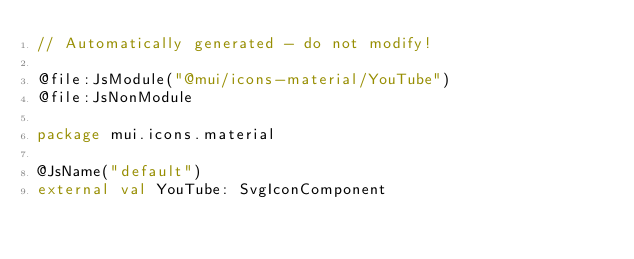<code> <loc_0><loc_0><loc_500><loc_500><_Kotlin_>// Automatically generated - do not modify!

@file:JsModule("@mui/icons-material/YouTube")
@file:JsNonModule

package mui.icons.material

@JsName("default")
external val YouTube: SvgIconComponent
</code> 